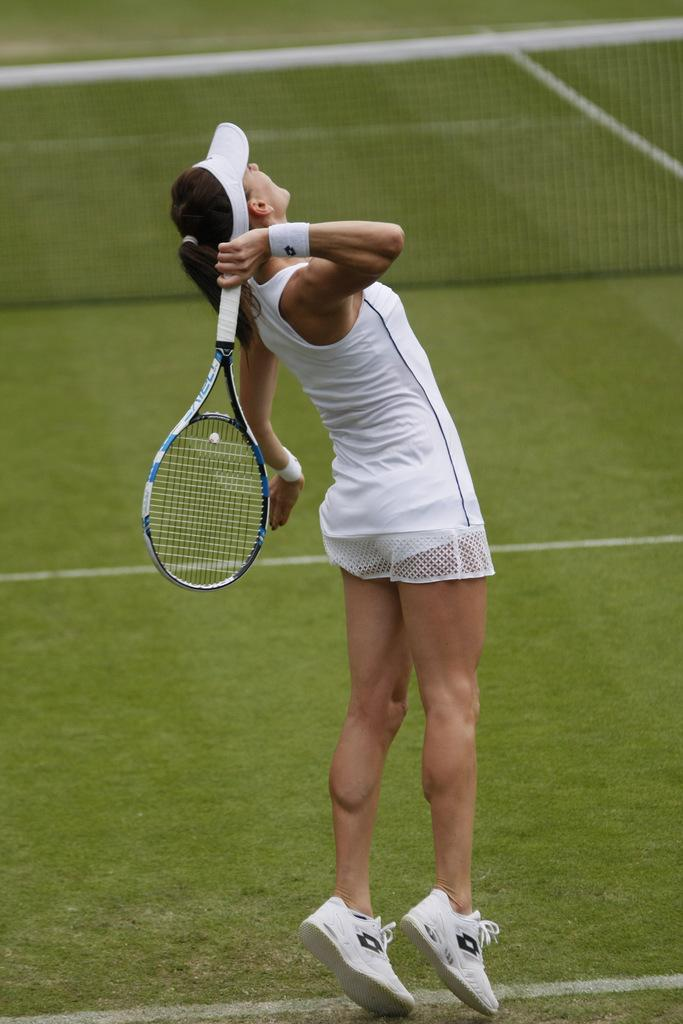Who is the main subject in the image? There is a lady in the image. What is the lady holding in the image? The lady is holding a badminton racket. What can be seen in the background of the image? There is a grassy area, a net, and an unspecified object in the background of the image. Where is the nest located in the image? There is no nest present in the image. Can you describe the parent's interaction with the child in the image? There is no parent or child present in the image. 